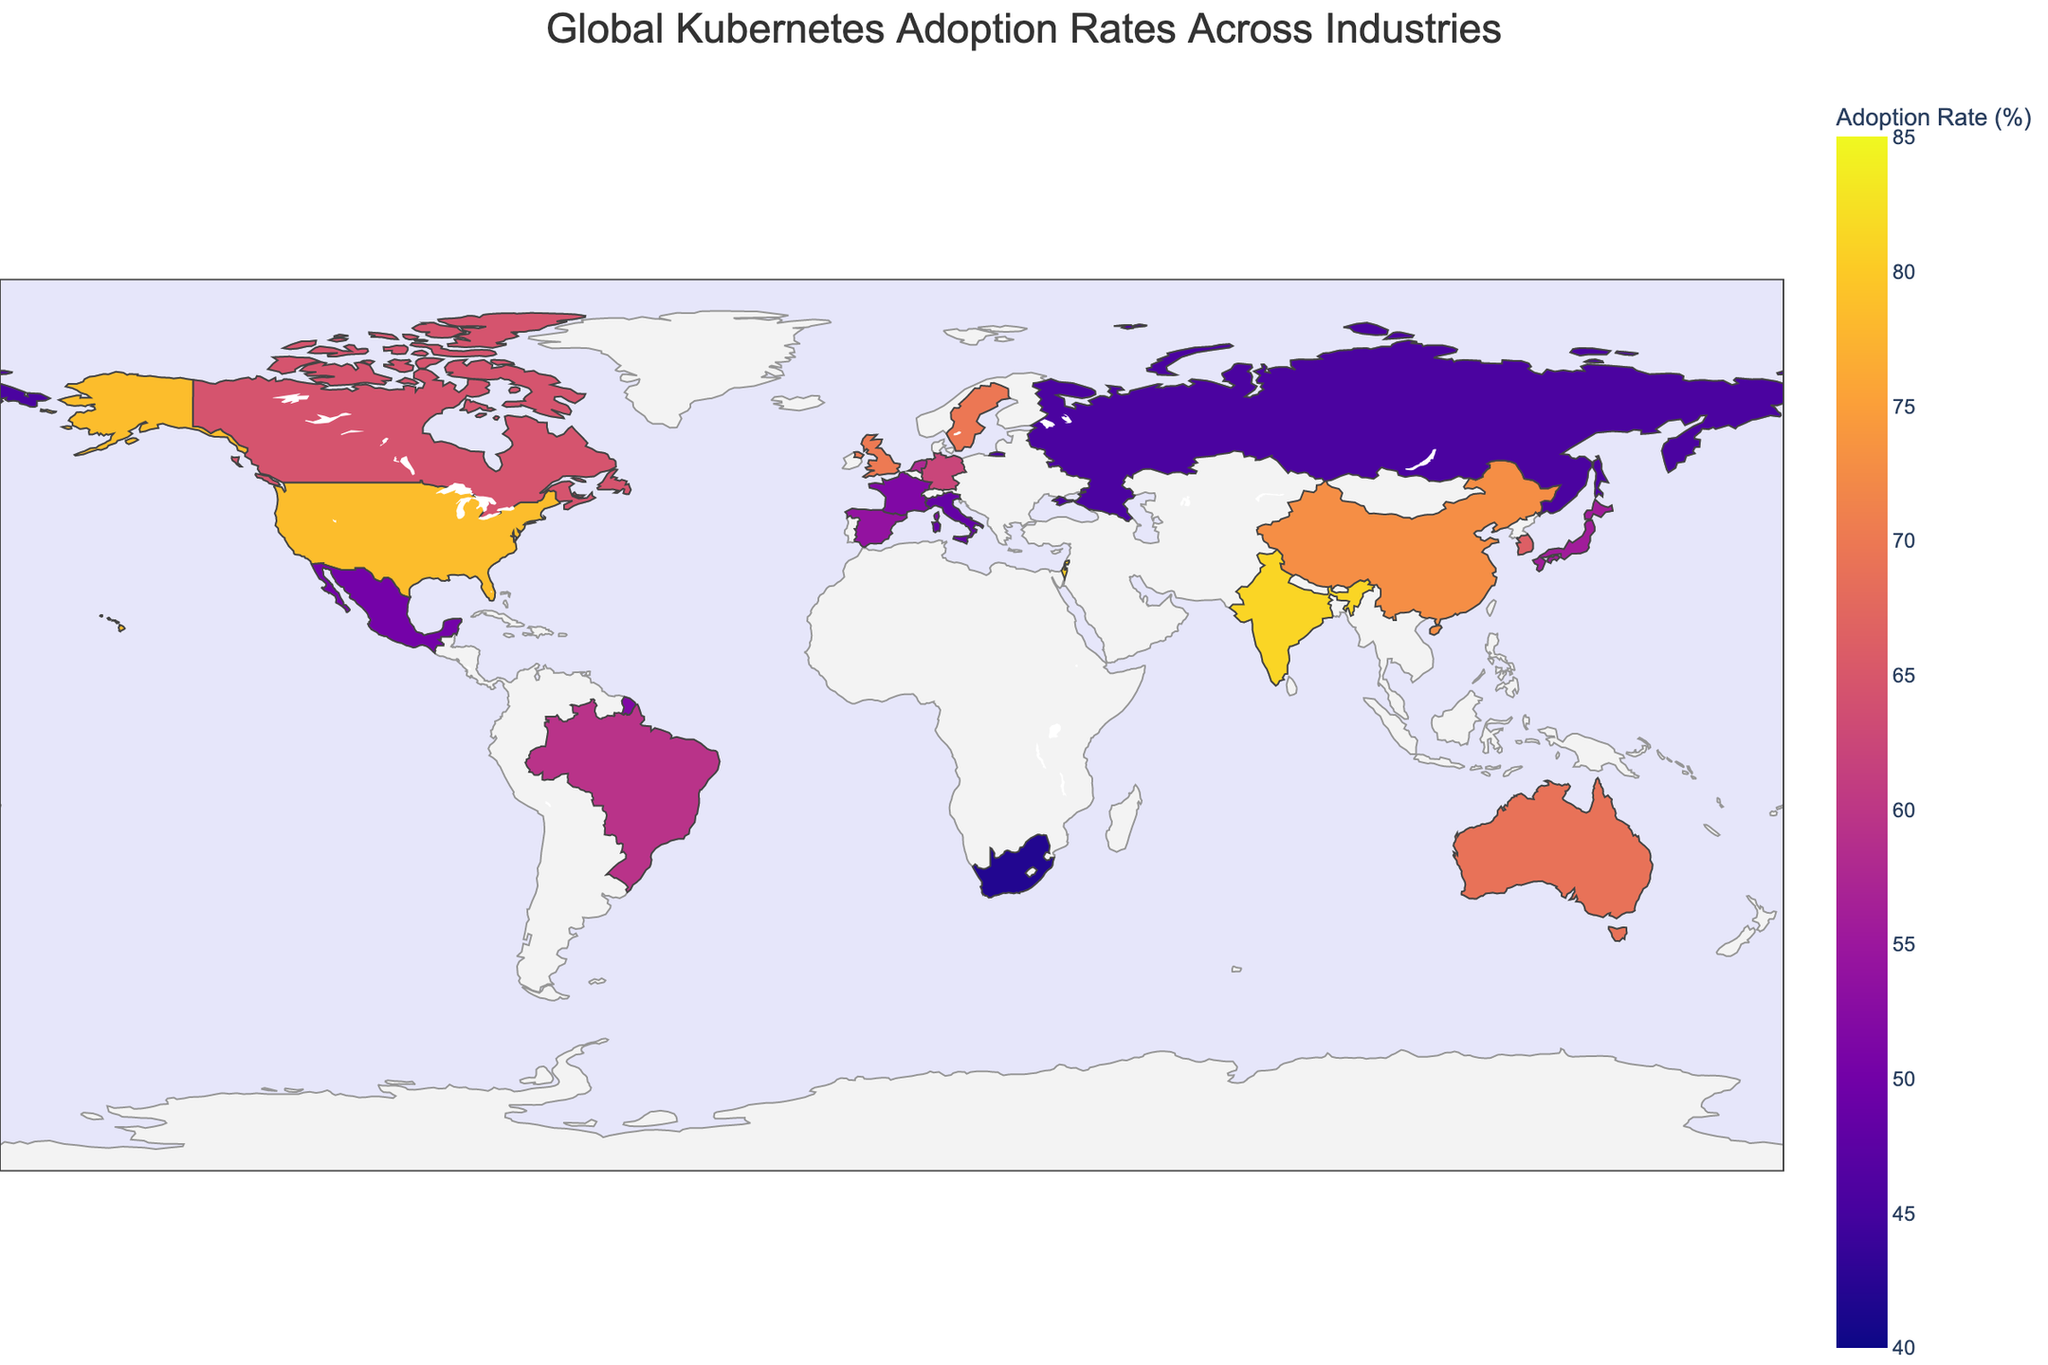What country has the highest Kubernetes adoption rate and in which industry? By examining the plot, we identify the data points and their corresponding adoption rates. The highest value, 81.2%, belongs to India, specifically in the IT Services industry.
Answer: India, IT Services Which country is leading in Kubernetes adoption in the FinTech industry? By looking for the industry label "FinTech" on the map, Singapore stands out with an adoption rate of 76.3%.
Answer: Singapore What is the average Kubernetes adoption rate of the Technology and Cybersecurity industries combined? Adding the adoption rates for the Technology (78.5% in the United States) and Cybersecurity (80.5% in Israel) industries and dividing by 2 gives (78.5 + 80.5)/2 = 79.5%.
Answer: 79.5% Comparing Brazil and Sweden, which country has a higher Kubernetes adoption rate and by how much? From the plot, Brazil's rate is 59.4% (Telecommunications) while Sweden's is 69.7% (Gaming). The difference is 69.7 - 59.4 = 10.3%.
Answer: Sweden by 10.3% Which sector in Canada has an adoption rate of 64.5%? Cross-referencing the country Canada's data point shows Media and Entertainment with a 64.5% adoption rate.
Answer: Media and Entertainment What is the color range used in the plot to indicate Kubernetes adoption rates? The color scale shown in the legend spans from 40% to 85%, represented in shades corresponding to the Plasma color sequence.
Answer: 40% to 85% How does the Kubernetes adoption rate in China's Cloud Services compare to Australia's E-commerce sector? China's Cloud Services adoption rate is 72.8%, and Australia's E-commerce is 68.9%. Therefore, China's rate is higher by 3.9%.
Answer: China by 3.9% What is the adoption rate for the Manufacturing sector in Japan, and how does it compare to the global maximum rate shown in the plot? Japan's Manufacturing sector has an adoption rate of 55.8%. The global maximum rate is 81.2% in India's IT Services sector, making Japan's rate 25.4% lower.
Answer: 55.8%, 25.4% lower List the countries with adoption rates below 50%. Looking at the plot, Russia (Aerospace, 45.6%), Italy (Energy, 48.4%), Mexico (Automotive, 50.2% barely above 50%), and South Africa (Mining, 41.8%) are displayed below 50%.
Answer: Russia, Italy, South Africa What is the range of adoption rates in the plot? The minimum adoption rate is 41.8% (South Africa, Mining) and the maximum is 81.2% (India, IT Services), so the range is 81.2 - 41.8 = 39.4%.
Answer: 39.4% 